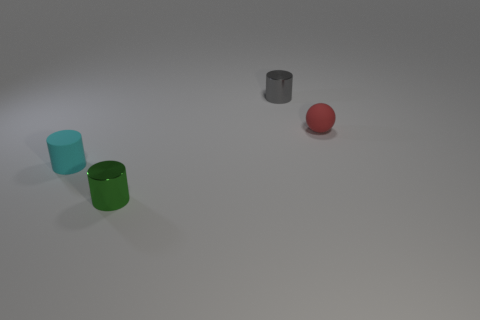Add 1 red matte things. How many objects exist? 5 Subtract all small metallic cylinders. How many cylinders are left? 1 Subtract all balls. How many objects are left? 3 Subtract all small shiny cylinders. Subtract all tiny balls. How many objects are left? 1 Add 4 metal things. How many metal things are left? 6 Add 1 big blue shiny cylinders. How many big blue shiny cylinders exist? 1 Subtract all green cylinders. How many cylinders are left? 2 Subtract 0 gray spheres. How many objects are left? 4 Subtract 1 balls. How many balls are left? 0 Subtract all red cylinders. Subtract all green spheres. How many cylinders are left? 3 